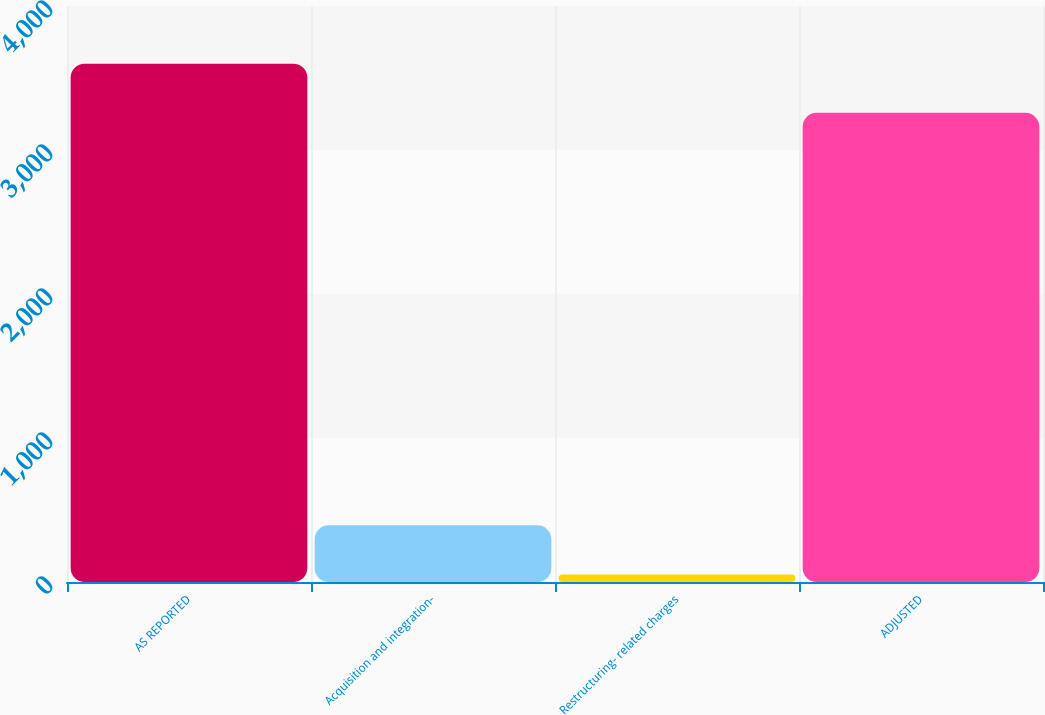Convert chart. <chart><loc_0><loc_0><loc_500><loc_500><bar_chart><fcel>AS REPORTED<fcel>Acquisition and integration-<fcel>Restructuring- related charges<fcel>ADJUSTED<nl><fcel>3599.5<fcel>393.5<fcel>52<fcel>3258<nl></chart> 